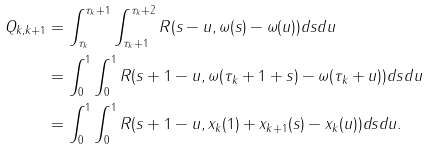<formula> <loc_0><loc_0><loc_500><loc_500>Q _ { k , k + 1 } & = \int _ { \tau _ { k } } ^ { \tau _ { k } + 1 } \int _ { \tau _ { k } + 1 } ^ { \tau _ { k } + 2 } R ( s - u , \omega ( s ) - \omega ( u ) ) d s d u \\ & = \int _ { 0 } ^ { 1 } \int _ { 0 } ^ { 1 } R ( s + 1 - u , \omega ( \tau _ { k } + 1 + s ) - \omega ( \tau _ { k } + u ) ) d s d u \\ & = \int _ { 0 } ^ { 1 } \int _ { 0 } ^ { 1 } R ( s + 1 - u , x _ { k } ( 1 ) + x _ { k + 1 } ( s ) - x _ { k } ( u ) ) d s d u .</formula> 